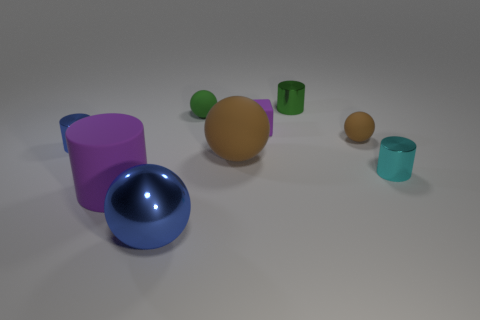Subtract all yellow spheres. Subtract all yellow cylinders. How many spheres are left? 4 Add 1 purple rubber things. How many objects exist? 10 Subtract all spheres. How many objects are left? 5 Add 1 large blue shiny objects. How many large blue shiny objects exist? 2 Subtract 0 yellow cubes. How many objects are left? 9 Subtract all large spheres. Subtract all tiny brown rubber things. How many objects are left? 6 Add 1 purple matte cylinders. How many purple matte cylinders are left? 2 